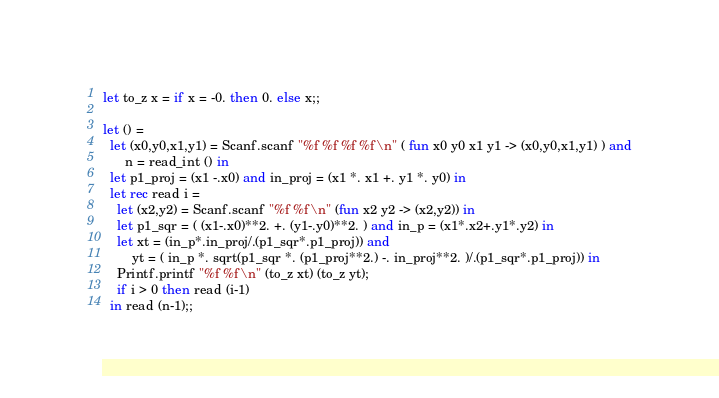<code> <loc_0><loc_0><loc_500><loc_500><_OCaml_>let to_z x = if x = -0. then 0. else x;;

let () =
  let (x0,y0,x1,y1) = Scanf.scanf "%f %f %f %f\n" ( fun x0 y0 x1 y1 -> (x0,y0,x1,y1) ) and
      n = read_int () in
  let p1_proj = (x1 -.x0) and in_proj = (x1 *. x1 +. y1 *. y0) in
  let rec read i =
    let (x2,y2) = Scanf.scanf "%f %f\n" (fun x2 y2 -> (x2,y2)) in
    let p1_sqr = ( (x1-.x0)**2. +. (y1-.y0)**2. ) and in_p = (x1*.x2+.y1*.y2) in
    let xt = (in_p*.in_proj/.(p1_sqr*.p1_proj)) and
        yt = ( in_p *. sqrt(p1_sqr *. (p1_proj**2.) -. in_proj**2. )/.(p1_sqr*.p1_proj)) in
    Printf.printf "%f %f\n" (to_z xt) (to_z yt);
    if i > 0 then read (i-1)
  in read (n-1);;</code> 